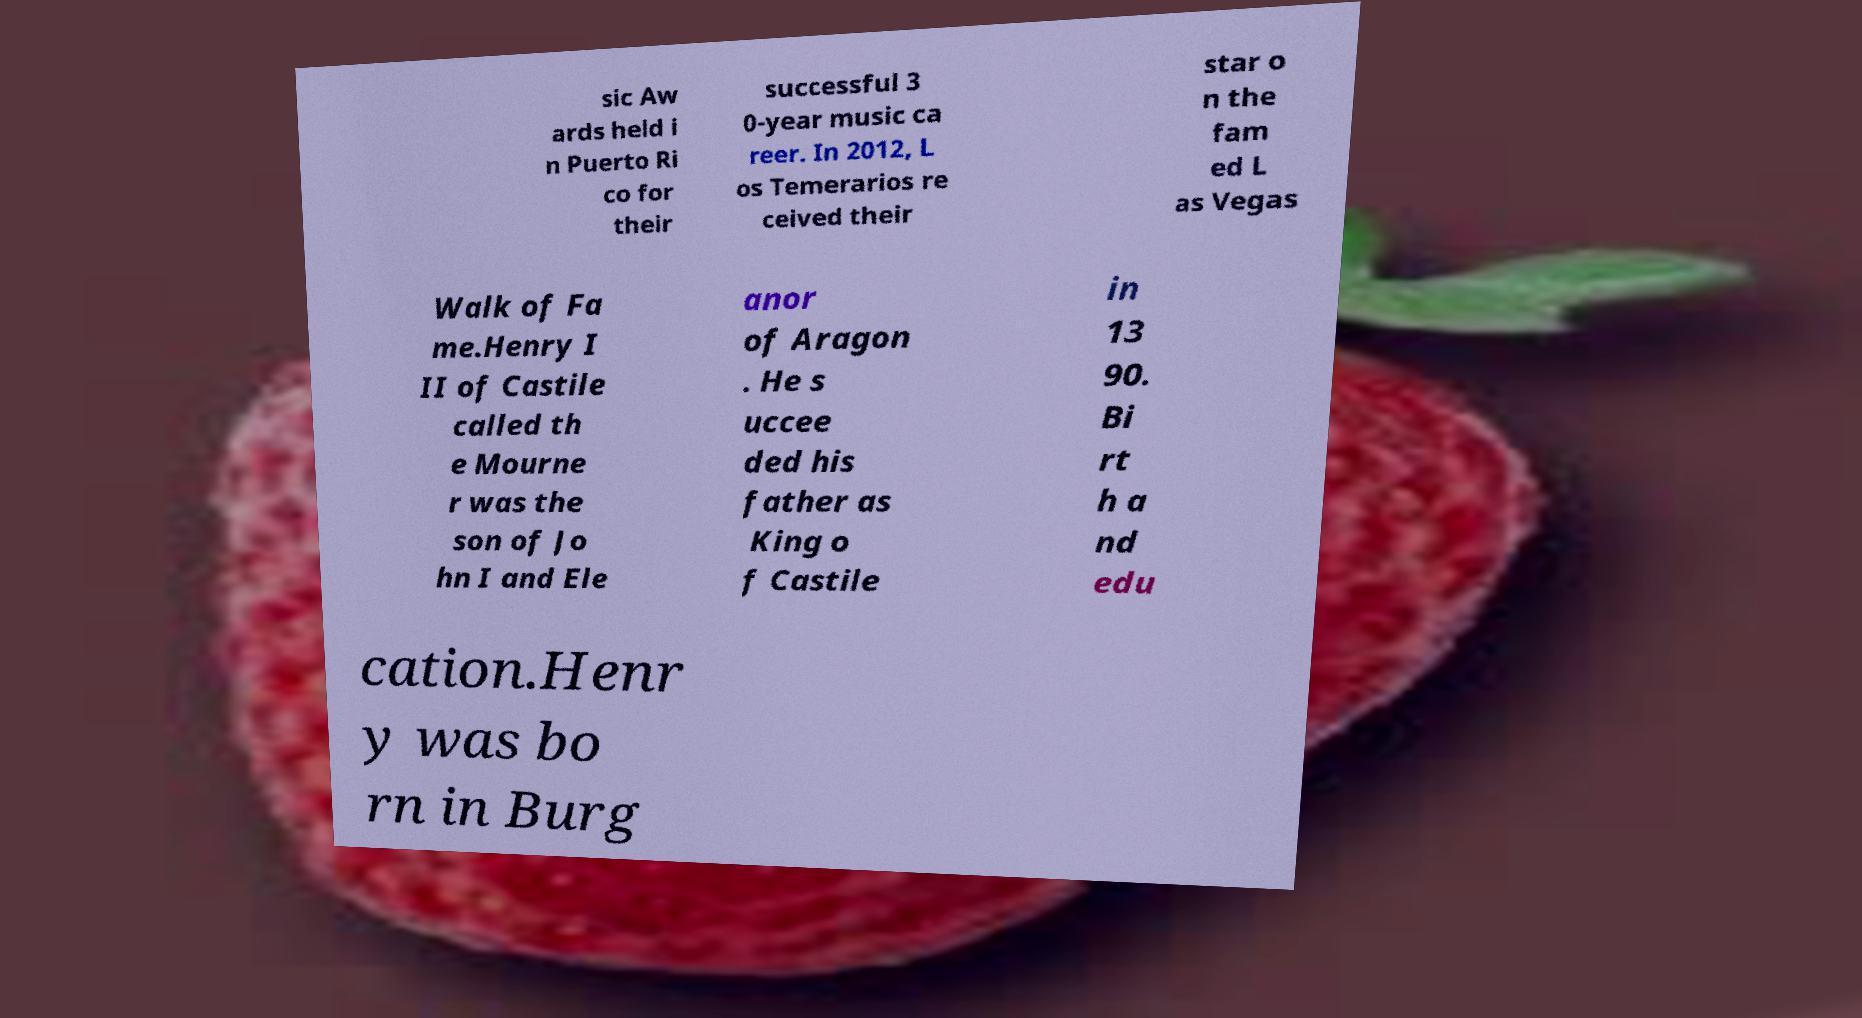What messages or text are displayed in this image? I need them in a readable, typed format. sic Aw ards held i n Puerto Ri co for their successful 3 0-year music ca reer. In 2012, L os Temerarios re ceived their star o n the fam ed L as Vegas Walk of Fa me.Henry I II of Castile called th e Mourne r was the son of Jo hn I and Ele anor of Aragon . He s uccee ded his father as King o f Castile in 13 90. Bi rt h a nd edu cation.Henr y was bo rn in Burg 